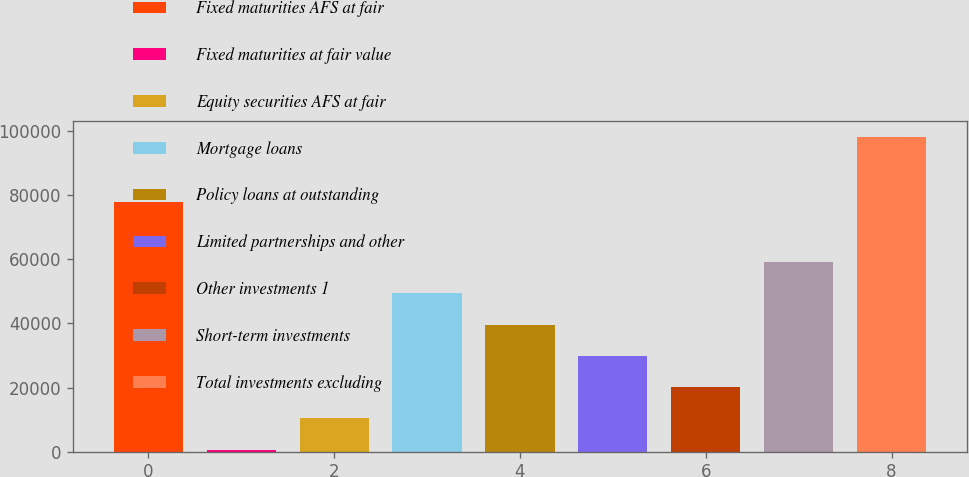Convert chart to OTSL. <chart><loc_0><loc_0><loc_500><loc_500><bar_chart><fcel>Fixed maturities AFS at fair<fcel>Fixed maturities at fair value<fcel>Equity securities AFS at fair<fcel>Mortgage loans<fcel>Policy loans at outstanding<fcel>Limited partnerships and other<fcel>Other investments 1<fcel>Short-term investments<fcel>Total investments excluding<nl><fcel>77820<fcel>649<fcel>10401.6<fcel>49412<fcel>39659.4<fcel>29906.8<fcel>20154.2<fcel>59164.6<fcel>98175<nl></chart> 